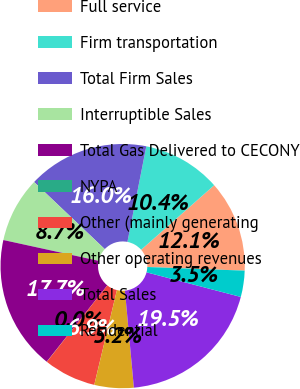Convert chart. <chart><loc_0><loc_0><loc_500><loc_500><pie_chart><fcel>Full service<fcel>Firm transportation<fcel>Total Firm Sales<fcel>Interruptible Sales<fcel>Total Gas Delivered to CECONY<fcel>NYPA<fcel>Other (mainly generating<fcel>Other operating revenues<fcel>Total Sales<fcel>Residential<nl><fcel>12.11%<fcel>10.38%<fcel>16.02%<fcel>8.66%<fcel>17.74%<fcel>0.02%<fcel>6.93%<fcel>5.2%<fcel>19.47%<fcel>3.47%<nl></chart> 